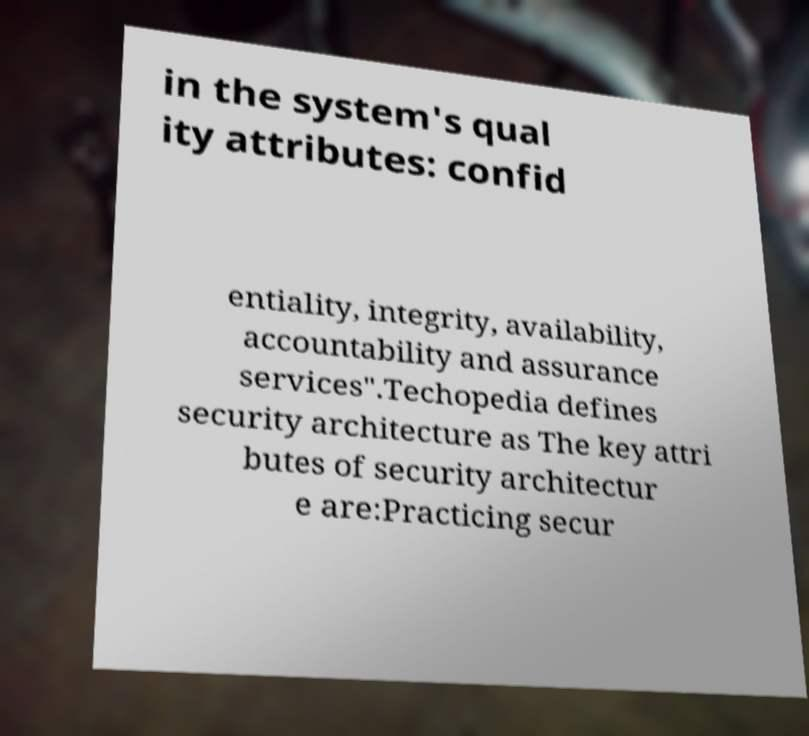Can you accurately transcribe the text from the provided image for me? in the system's qual ity attributes: confid entiality, integrity, availability, accountability and assurance services".Techopedia defines security architecture as The key attri butes of security architectur e are:Practicing secur 